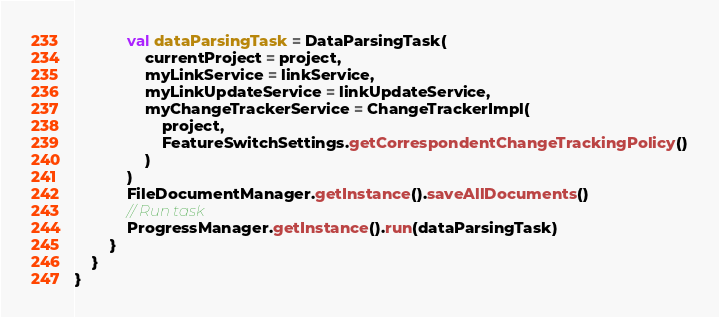<code> <loc_0><loc_0><loc_500><loc_500><_Kotlin_>            val dataParsingTask = DataParsingTask(
                currentProject = project,
                myLinkService = linkService,
                myLinkUpdateService = linkUpdateService,
                myChangeTrackerService = ChangeTrackerImpl(
                    project,
                    FeatureSwitchSettings.getCorrespondentChangeTrackingPolicy()
                )
            )
            FileDocumentManager.getInstance().saveAllDocuments()
            // Run task
            ProgressManager.getInstance().run(dataParsingTask)
        }
    }
}
</code> 